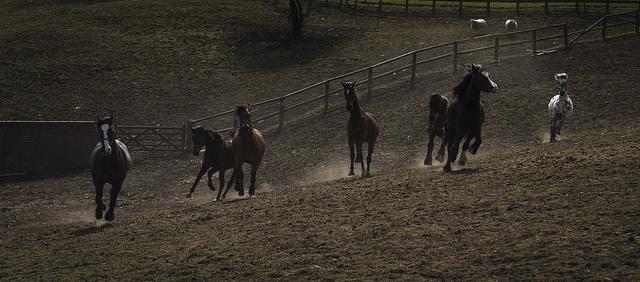Is this picture taken during the day?
Keep it brief. Yes. How many people are visible in this picture?
Keep it brief. 0. How many horses are in the picture?
Write a very short answer. 7. Is the horse in a city or in the country?
Quick response, please. Country. How many horses are running?
Be succinct. 7. 